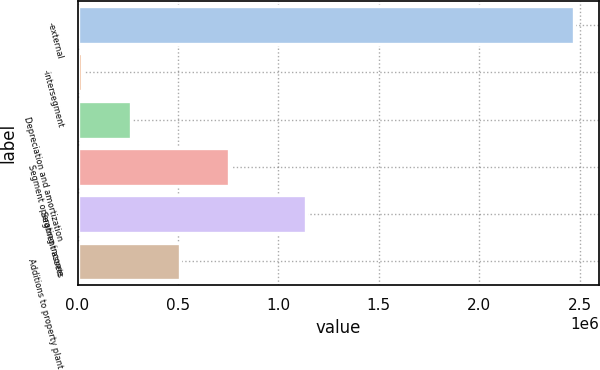<chart> <loc_0><loc_0><loc_500><loc_500><bar_chart><fcel>-external<fcel>-intersegment<fcel>Depreciation and amortization<fcel>Segment operating income<fcel>Segment assets<fcel>Additions to property plant<nl><fcel>2.47143e+06<fcel>20767<fcel>265833<fcel>755966<fcel>1.13987e+06<fcel>510900<nl></chart> 